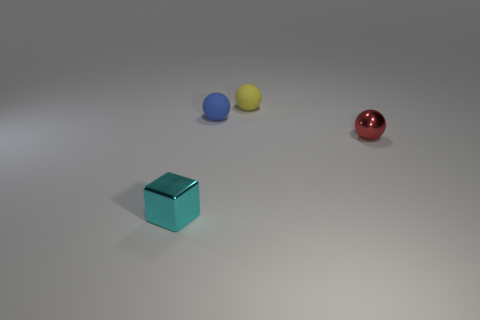Is there any other thing of the same color as the small block?
Ensure brevity in your answer.  No. There is a thing that is on the left side of the small blue rubber sphere; is it the same shape as the metallic thing that is behind the small metallic cube?
Provide a succinct answer. No. How many objects are either yellow spheres or metallic objects that are in front of the red ball?
Your response must be concise. 2. How many other things are the same size as the blue thing?
Provide a succinct answer. 3. Are the sphere behind the tiny blue sphere and the ball to the left of the tiny yellow thing made of the same material?
Ensure brevity in your answer.  Yes. There is a small cyan metallic object; how many tiny things are on the left side of it?
Keep it short and to the point. 0. How many brown objects are shiny objects or big things?
Offer a terse response. 0. There is a red sphere that is the same size as the metal block; what is its material?
Ensure brevity in your answer.  Metal. What shape is the tiny thing that is left of the yellow ball and right of the small cyan block?
Offer a very short reply. Sphere. What color is the metallic object that is the same size as the red metal sphere?
Your answer should be very brief. Cyan. 